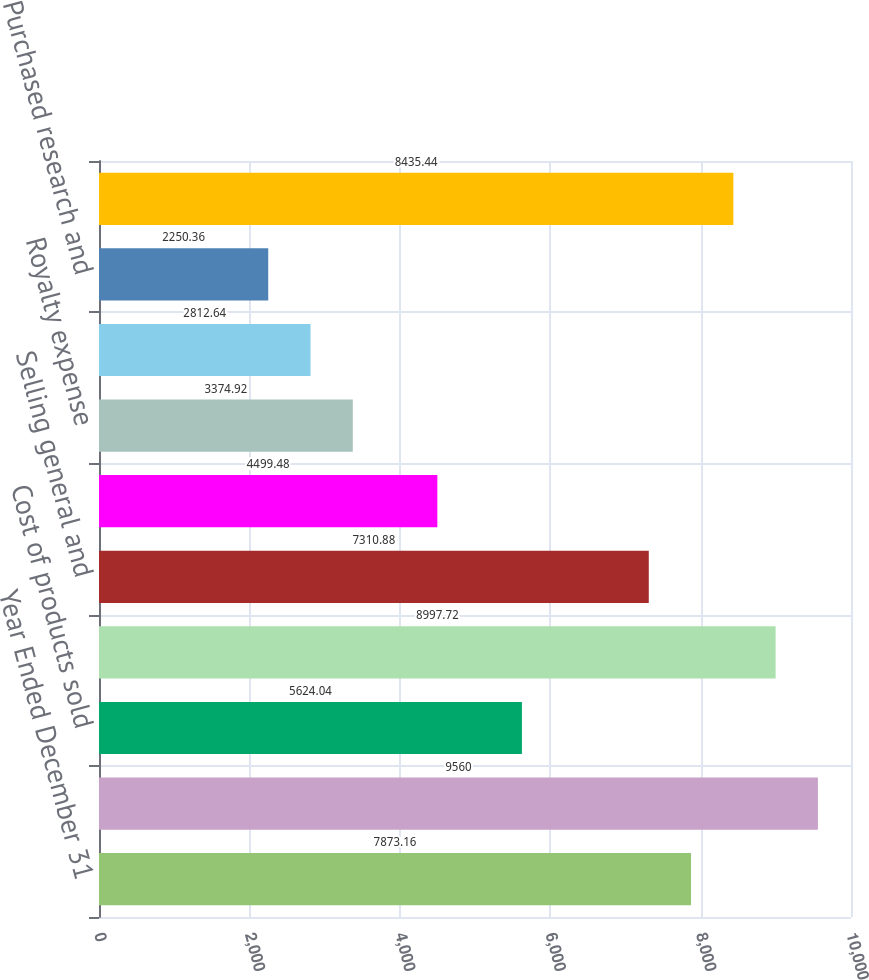Convert chart. <chart><loc_0><loc_0><loc_500><loc_500><bar_chart><fcel>Year Ended December 31<fcel>Net sales<fcel>Cost of products sold<fcel>Gross profit<fcel>Selling general and<fcel>Research and development<fcel>Royalty expense<fcel>Amortization expense<fcel>Purchased research and<fcel>Total operating expenses<nl><fcel>7873.16<fcel>9560<fcel>5624.04<fcel>8997.72<fcel>7310.88<fcel>4499.48<fcel>3374.92<fcel>2812.64<fcel>2250.36<fcel>8435.44<nl></chart> 